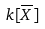<formula> <loc_0><loc_0><loc_500><loc_500>k [ { \overline { X } } ]</formula> 